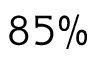<formula> <loc_0><loc_0><loc_500><loc_500>8 5 \%</formula> 